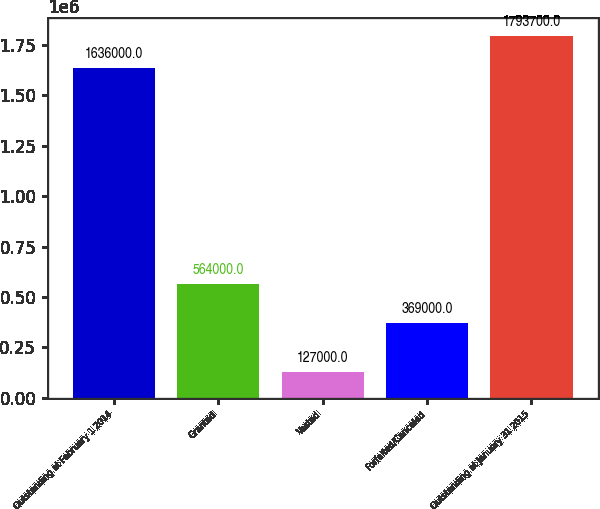Convert chart. <chart><loc_0><loc_0><loc_500><loc_500><bar_chart><fcel>Outstanding at February 1 2014<fcel>Granted<fcel>Vested<fcel>Forfeited/Canceled<fcel>Outstanding at January 31 2015<nl><fcel>1.636e+06<fcel>564000<fcel>127000<fcel>369000<fcel>1.7937e+06<nl></chart> 